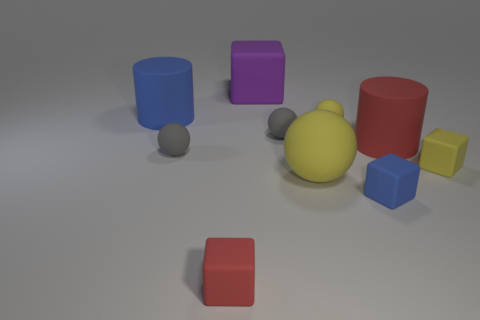How many yellow balls must be subtracted to get 1 yellow balls? 1 Subtract 1 cubes. How many cubes are left? 3 Subtract all cubes. How many objects are left? 6 Subtract 0 red spheres. How many objects are left? 10 Subtract all large gray metallic blocks. Subtract all blue blocks. How many objects are left? 9 Add 2 big purple things. How many big purple things are left? 3 Add 1 big green shiny spheres. How many big green shiny spheres exist? 1 